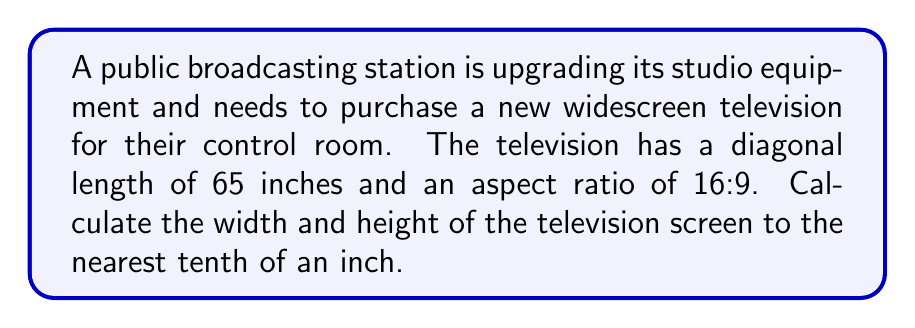What is the answer to this math problem? Let's approach this step-by-step:

1) Let the width be $w$ and the height be $h$.

2) The aspect ratio of 16:9 means that $\frac{w}{h} = \frac{16}{9}$.

3) We can express this as: $w = \frac{16}{9}h$.

4) Using the Pythagorean theorem for the diagonal $d$:

   $$d^2 = w^2 + h^2$$

5) Substituting $w = \frac{16}{9}h$ into this equation:

   $$65^2 = (\frac{16}{9}h)^2 + h^2$$

6) Simplify:

   $$4225 = \frac{256}{81}h^2 + h^2 = \frac{256}{81}h^2 + \frac{81}{81}h^2 = \frac{337}{81}h^2$$

7) Solve for $h$:

   $$h^2 = \frac{4225 \times 81}{337} \approx 1013.72$$
   $$h \approx \sqrt{1013.72} \approx 31.84$$

8) Round $h$ to the nearest tenth: $h \approx 31.8$ inches

9) Calculate $w$ using the aspect ratio:

   $$w = \frac{16}{9}h \approx \frac{16}{9} \times 31.8 \approx 56.53$$

10) Round $w$ to the nearest tenth: $w \approx 56.5$ inches
Answer: Width: 56.5 inches, Height: 31.8 inches 